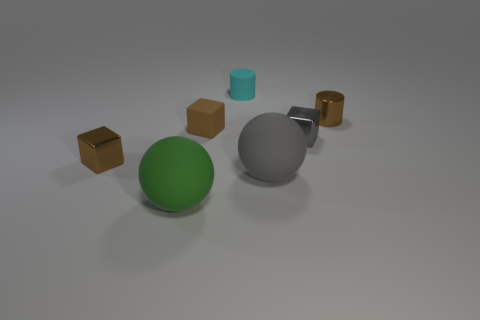Subtract all brown blocks. How many blocks are left? 1 Add 1 big blue metallic balls. How many objects exist? 8 Subtract all brown cylinders. How many brown blocks are left? 2 Subtract all cyan cylinders. How many cylinders are left? 1 Subtract all balls. How many objects are left? 5 Add 3 tiny cyan cylinders. How many tiny cyan cylinders are left? 4 Add 6 small purple rubber balls. How many small purple rubber balls exist? 6 Subtract 1 brown cylinders. How many objects are left? 6 Subtract all yellow spheres. Subtract all green cubes. How many spheres are left? 2 Subtract all large red balls. Subtract all big gray matte things. How many objects are left? 6 